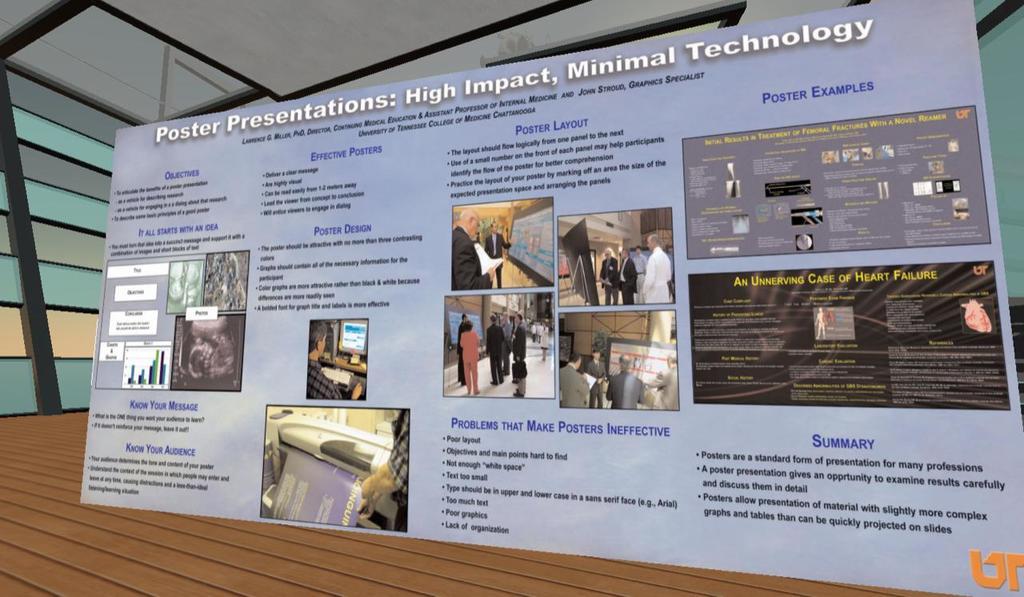What is the headline?
Keep it short and to the point. Poster presentations: high impact, minimal technology. What is the heading for the paragraph on the bottom right?
Ensure brevity in your answer.  Summary. 